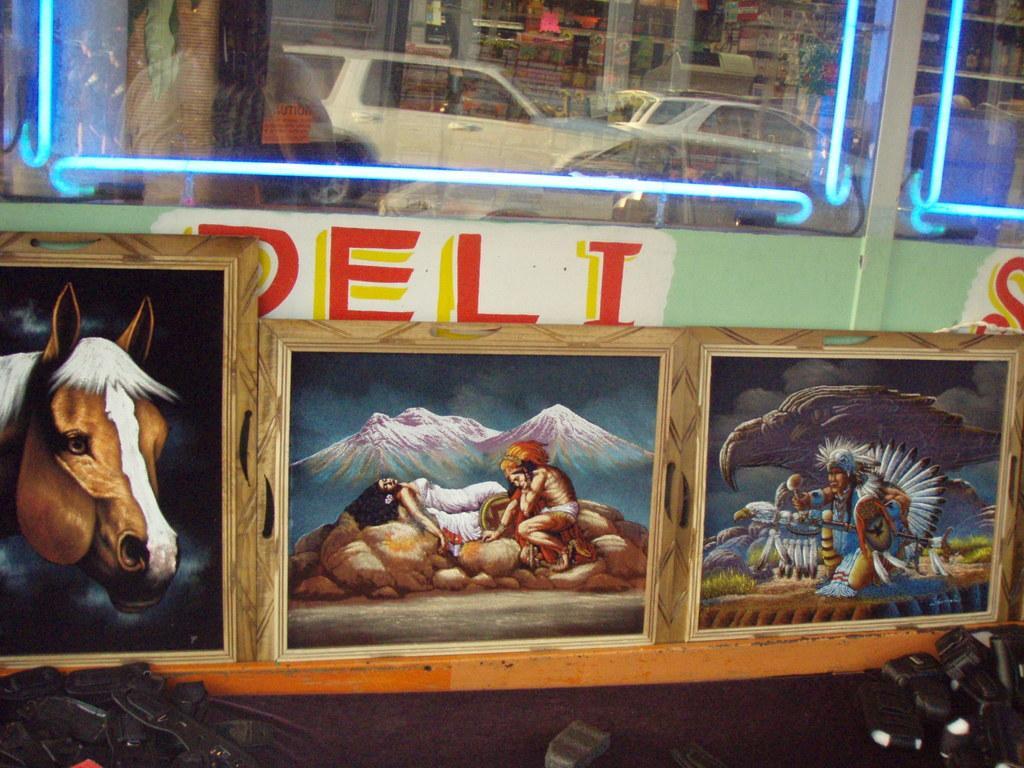Could you give a brief overview of what you see in this image? In this image we can see some photo frames on a wall with the pictures on them. We can also see some text on a wall. On the bottom of the image we can see some objects placed on the surface. On the top of the image we can see some cars from a window and some lights. 